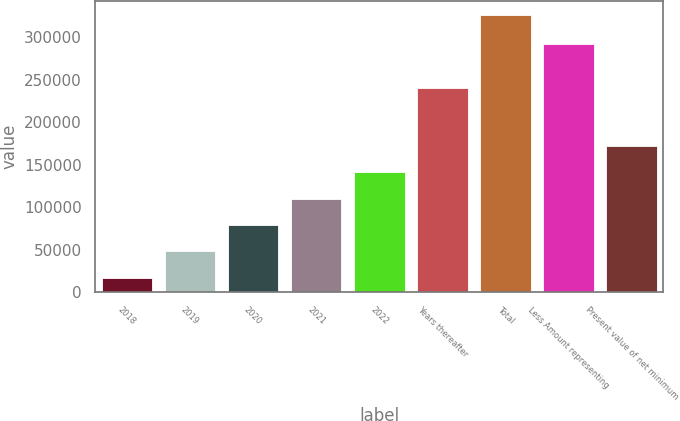Convert chart. <chart><loc_0><loc_0><loc_500><loc_500><bar_chart><fcel>2018<fcel>2019<fcel>2020<fcel>2021<fcel>2022<fcel>Years thereafter<fcel>Total<fcel>Less Amount representing<fcel>Present value of net minimum<nl><fcel>17188<fcel>48125.7<fcel>79063.4<fcel>110001<fcel>140939<fcel>240625<fcel>326565<fcel>292209<fcel>171876<nl></chart> 